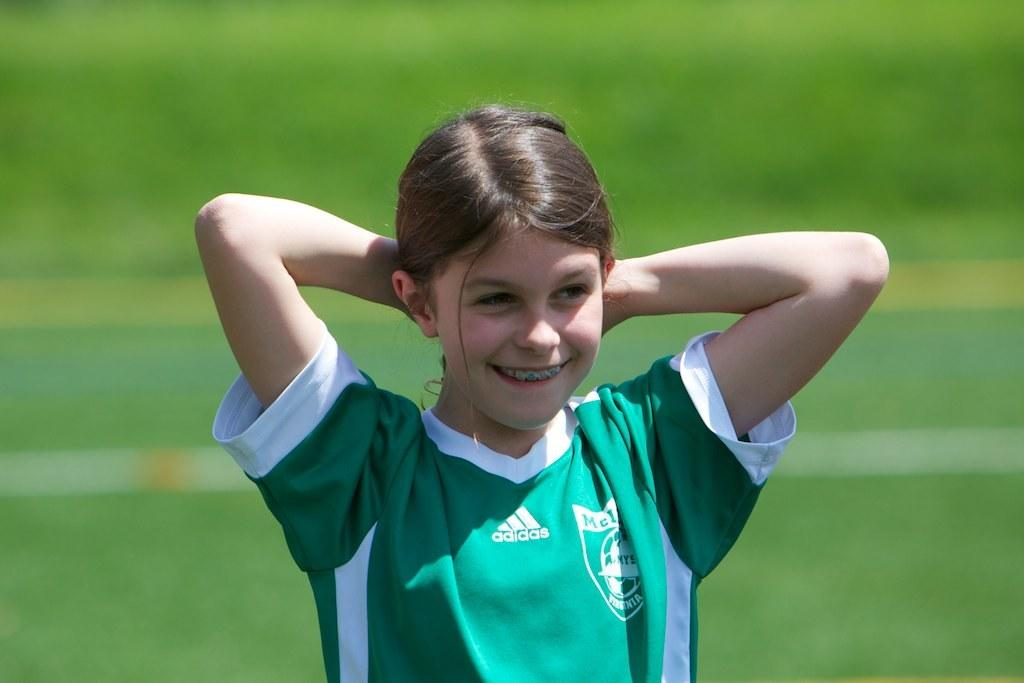<image>
Render a clear and concise summary of the photo. A girl wearing a green and white Adidas shirt. 